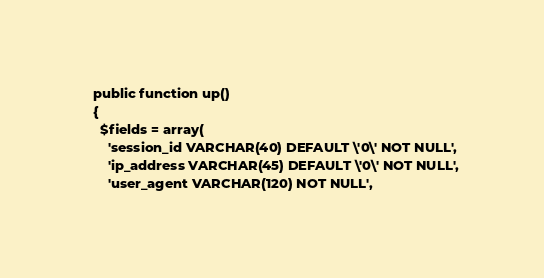Convert code to text. <code><loc_0><loc_0><loc_500><loc_500><_PHP_>
  public function up()
  {
    $fields = array(
      'session_id VARCHAR(40) DEFAULT \'0\' NOT NULL',
      'ip_address VARCHAR(45) DEFAULT \'0\' NOT NULL',
      'user_agent VARCHAR(120) NOT NULL',</code> 